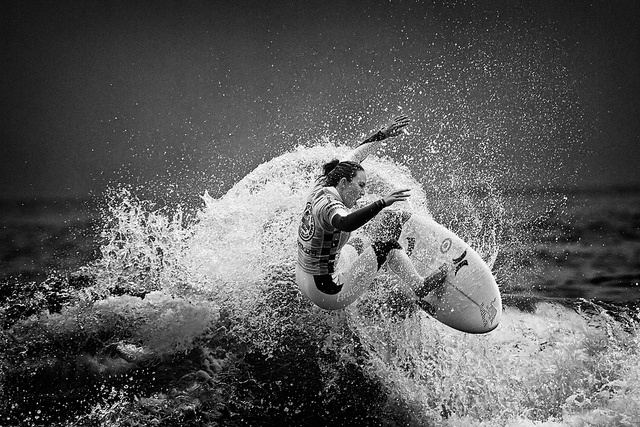Describe the objects in this image and their specific colors. I can see people in black, gray, darkgray, and lightgray tones and surfboard in black, darkgray, lightgray, and gray tones in this image. 